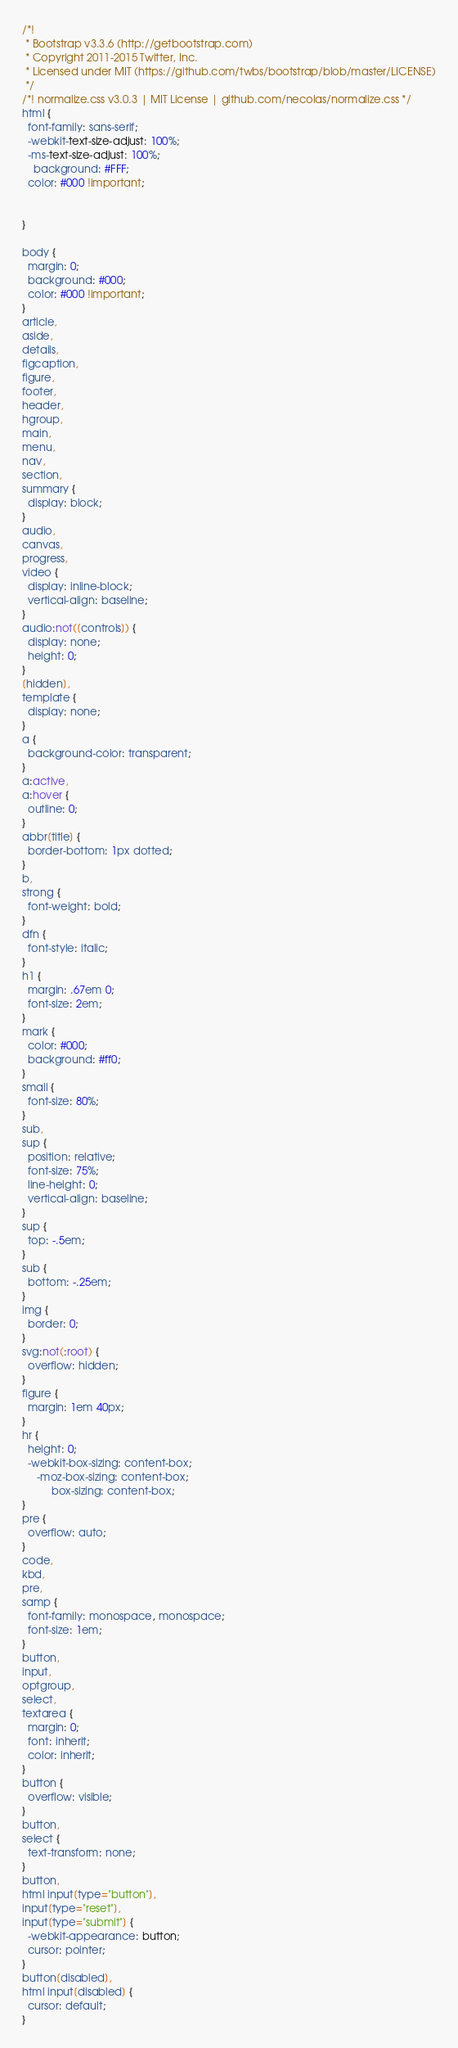<code> <loc_0><loc_0><loc_500><loc_500><_CSS_>/*!
 * Bootstrap v3.3.6 (http://getbootstrap.com)
 * Copyright 2011-2015 Twitter, Inc.
 * Licensed under MIT (https://github.com/twbs/bootstrap/blob/master/LICENSE)
 */
/*! normalize.css v3.0.3 | MIT License | github.com/necolas/normalize.css */
html {
  font-family: sans-serif;
  -webkit-text-size-adjust: 100%;
  -ms-text-size-adjust: 100%;
	background: #FFF;
  color: #000 !important;
  

}

body {
  margin: 0;
  background: #000;
  color: #000 !important;
}
article,
aside,
details,
figcaption,
figure,
footer,
header,
hgroup,
main,
menu,
nav,
section,
summary {
  display: block;
}
audio,
canvas,
progress,
video {
  display: inline-block;
  vertical-align: baseline;
}
audio:not([controls]) {
  display: none;
  height: 0;
}
[hidden],
template {
  display: none;
}
a {
  background-color: transparent;
}
a:active,
a:hover {
  outline: 0;
}
abbr[title] {
  border-bottom: 1px dotted;
}
b,
strong {
  font-weight: bold;
}
dfn {
  font-style: italic;
}
h1 {
  margin: .67em 0;
  font-size: 2em;
}
mark {
  color: #000;
  background: #ff0;
}
small {
  font-size: 80%;
}
sub,
sup {
  position: relative;
  font-size: 75%;
  line-height: 0;
  vertical-align: baseline;
}
sup {
  top: -.5em;
}
sub {
  bottom: -.25em;
}
img {
  border: 0;
}
svg:not(:root) {
  overflow: hidden;
}
figure {
  margin: 1em 40px;
}
hr {
  height: 0;
  -webkit-box-sizing: content-box;
     -moz-box-sizing: content-box;
          box-sizing: content-box;
}
pre {
  overflow: auto;
}
code,
kbd,
pre,
samp {
  font-family: monospace, monospace;
  font-size: 1em;
}
button,
input,
optgroup,
select,
textarea {
  margin: 0;
  font: inherit;
  color: inherit;
}
button {
  overflow: visible;
}
button,
select {
  text-transform: none;
}
button,
html input[type="button"],
input[type="reset"],
input[type="submit"] {
  -webkit-appearance: button;
  cursor: pointer;
}
button[disabled],
html input[disabled] {
  cursor: default;
}</code> 